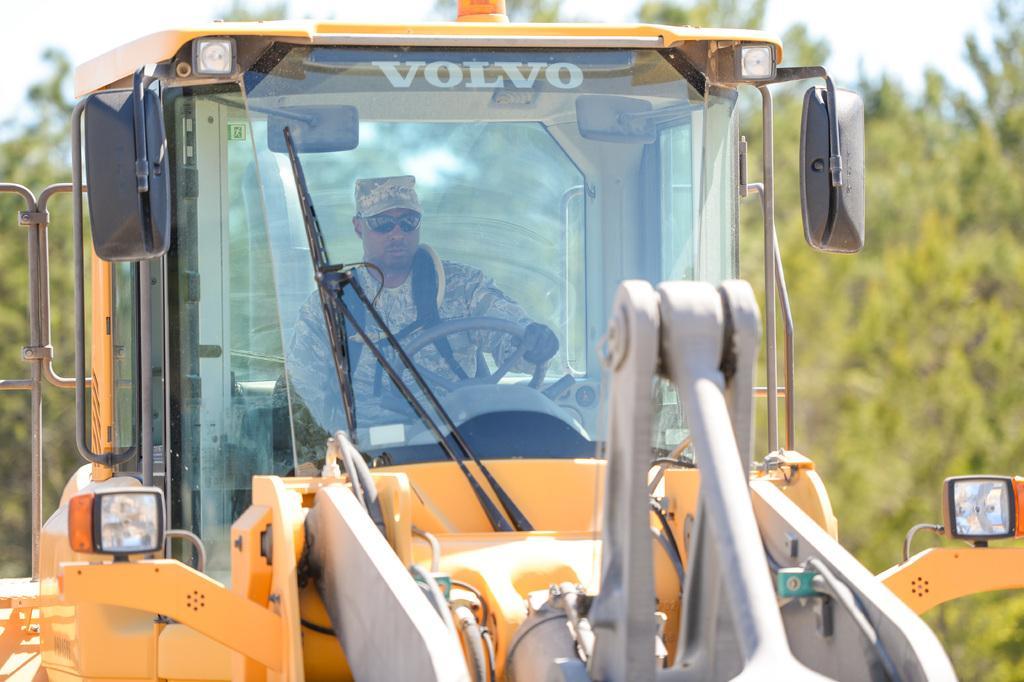In one or two sentences, can you explain what this image depicts? in this picture we can see a army person driving a crane and there is a text written "volvo" on it and a siren on the top. right side there are few trees 